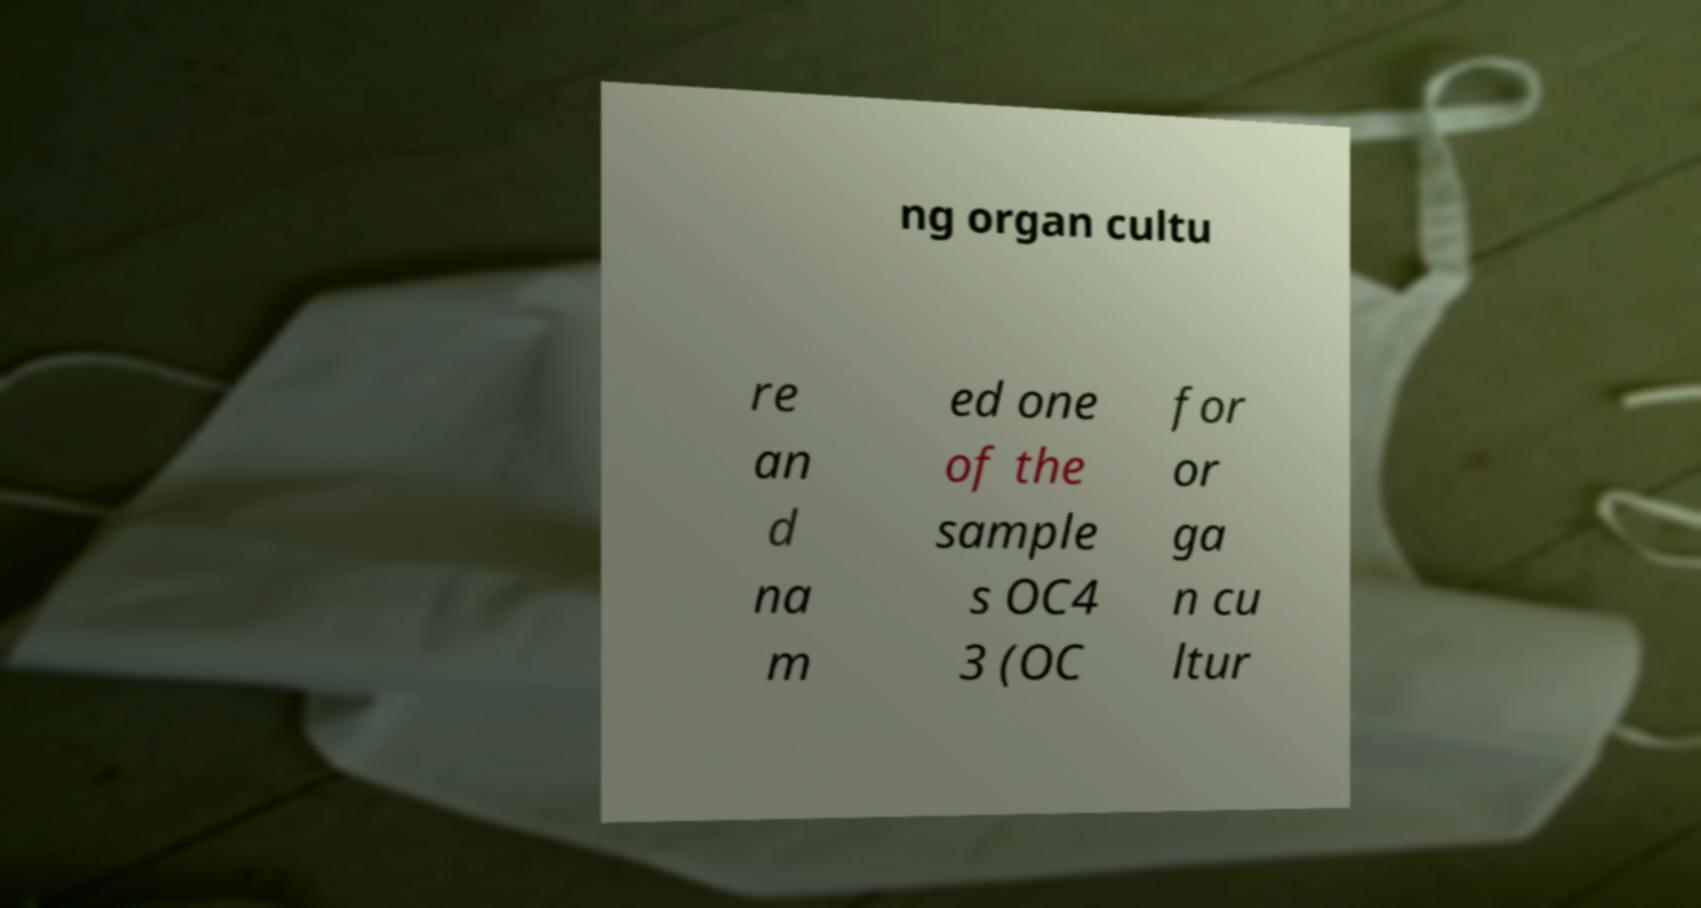What messages or text are displayed in this image? I need them in a readable, typed format. ng organ cultu re an d na m ed one of the sample s OC4 3 (OC for or ga n cu ltur 